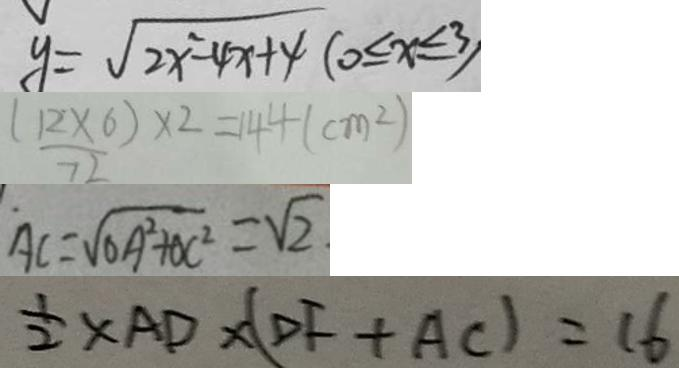<formula> <loc_0><loc_0><loc_500><loc_500>y = \sqrt { 2 x ^ { 2 } - 4 x + 4 } ( 0 \leq x \leq 3 ) 
 ( 1 2 \times 6 ) \times 2 = 1 4 4 ( c m ^ { 2 } ) 
 A C = \sqrt { O A ^ { 2 } + O C ^ { 2 } } = \sqrt { 2 } \cdot 
 \frac { 1 } { 2 } \times A D \times ( D F + A C ) = 1 6</formula> 